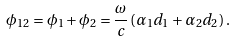<formula> <loc_0><loc_0><loc_500><loc_500>\phi _ { 1 2 } = \phi _ { 1 } + \phi _ { 2 } = \frac { \omega } { c } \left ( \alpha _ { 1 } d _ { 1 } + \alpha _ { 2 } d _ { 2 } \right ) .</formula> 